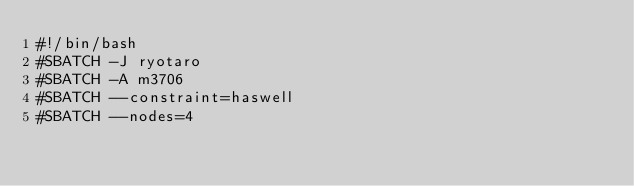<code> <loc_0><loc_0><loc_500><loc_500><_Bash_>#!/bin/bash
#SBATCH -J ryotaro
#SBATCH -A m3706
#SBATCH --constraint=haswell
#SBATCH --nodes=4</code> 